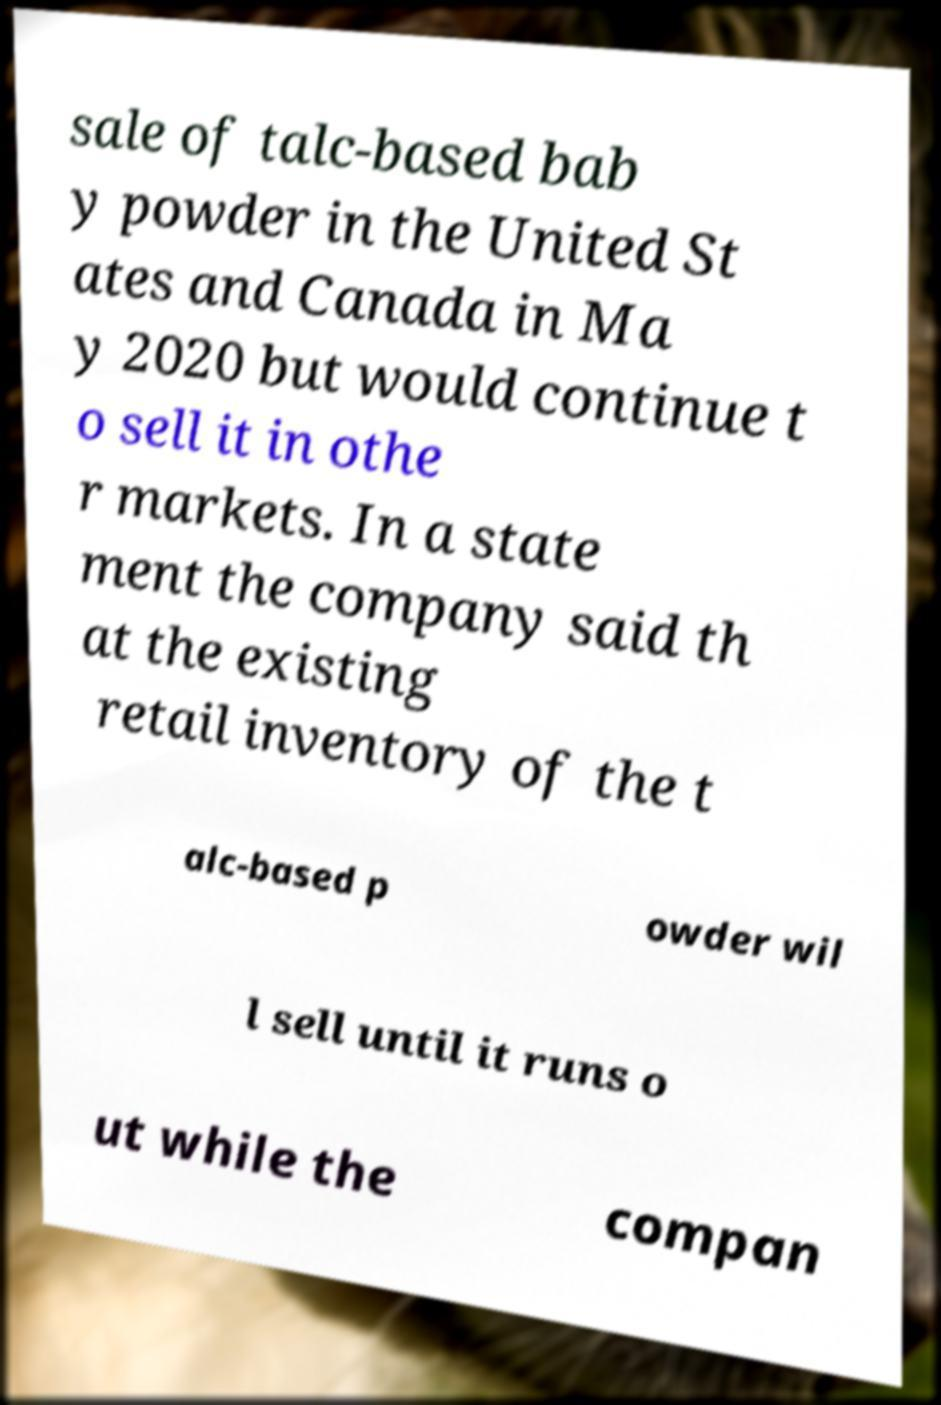Can you accurately transcribe the text from the provided image for me? sale of talc-based bab y powder in the United St ates and Canada in Ma y 2020 but would continue t o sell it in othe r markets. In a state ment the company said th at the existing retail inventory of the t alc-based p owder wil l sell until it runs o ut while the compan 